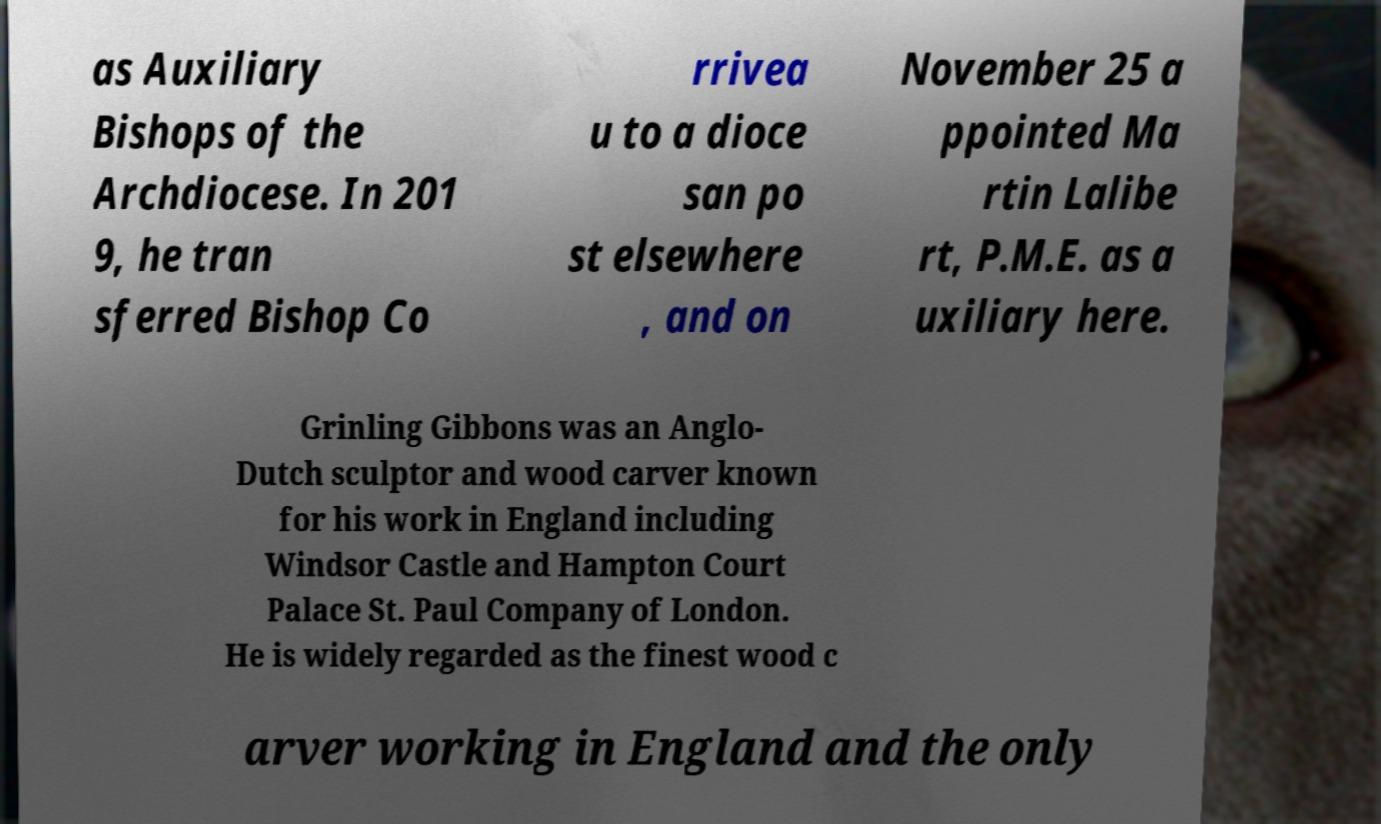Could you assist in decoding the text presented in this image and type it out clearly? as Auxiliary Bishops of the Archdiocese. In 201 9, he tran sferred Bishop Co rrivea u to a dioce san po st elsewhere , and on November 25 a ppointed Ma rtin Lalibe rt, P.M.E. as a uxiliary here. Grinling Gibbons was an Anglo- Dutch sculptor and wood carver known for his work in England including Windsor Castle and Hampton Court Palace St. Paul Company of London. He is widely regarded as the finest wood c arver working in England and the only 